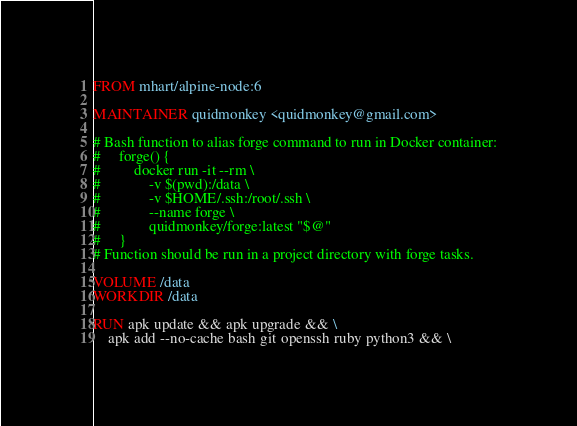<code> <loc_0><loc_0><loc_500><loc_500><_Dockerfile_>FROM mhart/alpine-node:6

MAINTAINER quidmonkey <quidmonkey@gmail.com>

# Bash function to alias forge command to run in Docker container:
#     forge() {
#         docker run -it --rm \
#             -v $(pwd):/data \
#             -v $HOME/.ssh:/root/.ssh \
#             --name forge \
#             quidmonkey/forge:latest "$@"
#     }
# Function should be run in a project directory with forge tasks.

VOLUME /data
WORKDIR /data

RUN apk update && apk upgrade && \
    apk add --no-cache bash git openssh ruby python3 && \</code> 